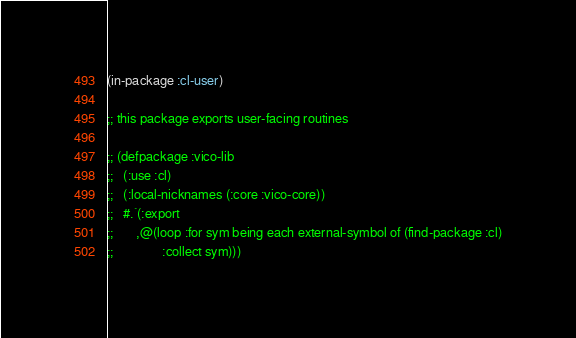<code> <loc_0><loc_0><loc_500><loc_500><_Lisp_>(in-package :cl-user)

;; this package exports user-facing routines

;; (defpackage :vico-lib
;;   (:use :cl)
;;   (:local-nicknames (:core :vico-core))
;;   #.`(:export
;;       ,@(loop :for sym being each external-symbol of (find-package :cl)
;;               :collect sym)))
</code> 